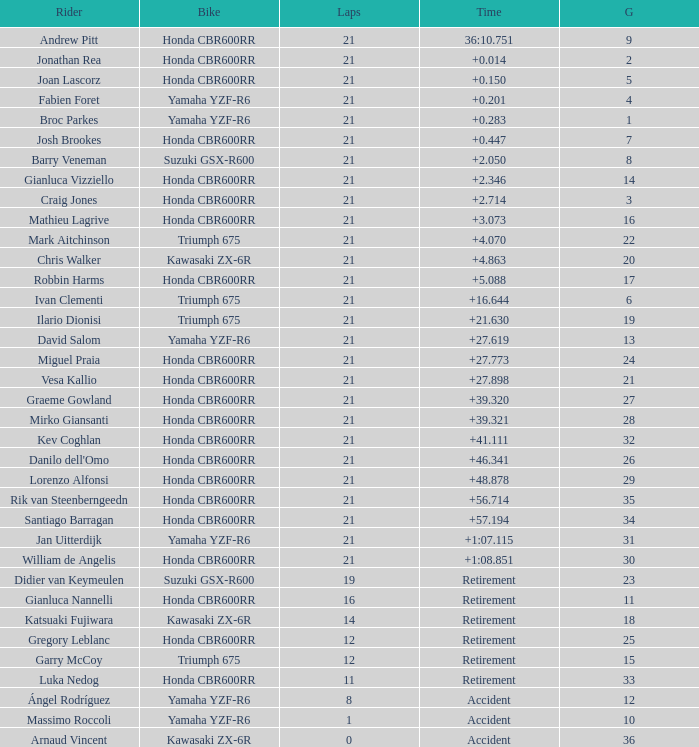What is the total of laps run by the driver with a grid under 17 and a time of +5.088? None. 